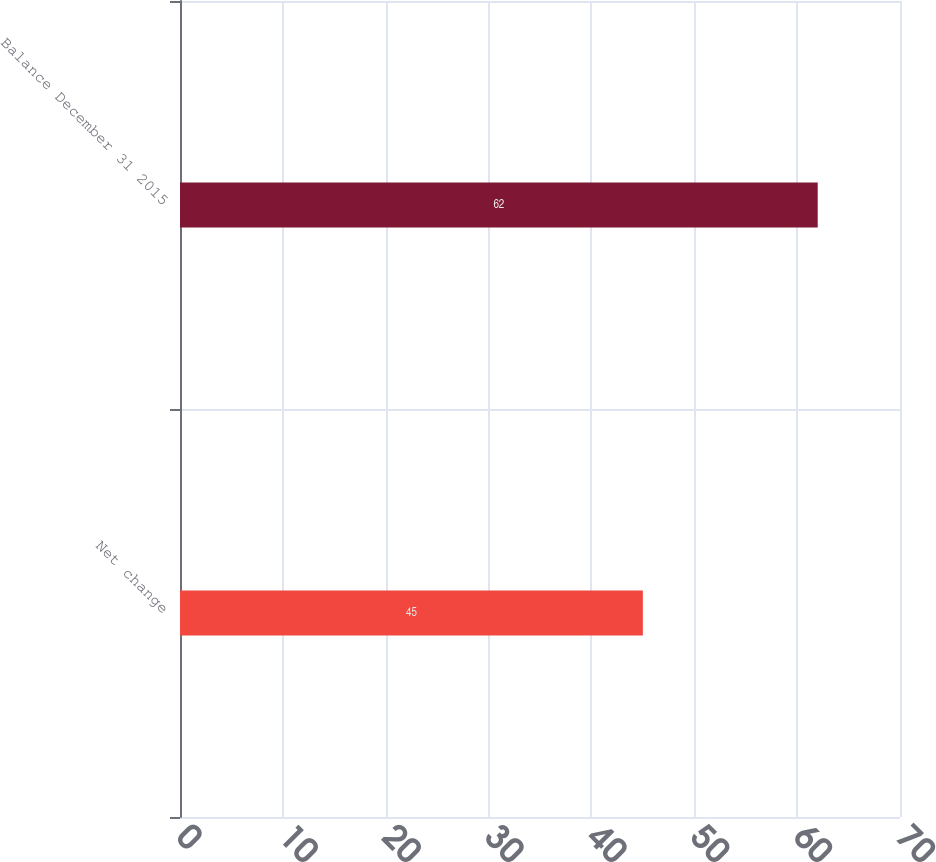<chart> <loc_0><loc_0><loc_500><loc_500><bar_chart><fcel>Net change<fcel>Balance December 31 2015<nl><fcel>45<fcel>62<nl></chart> 